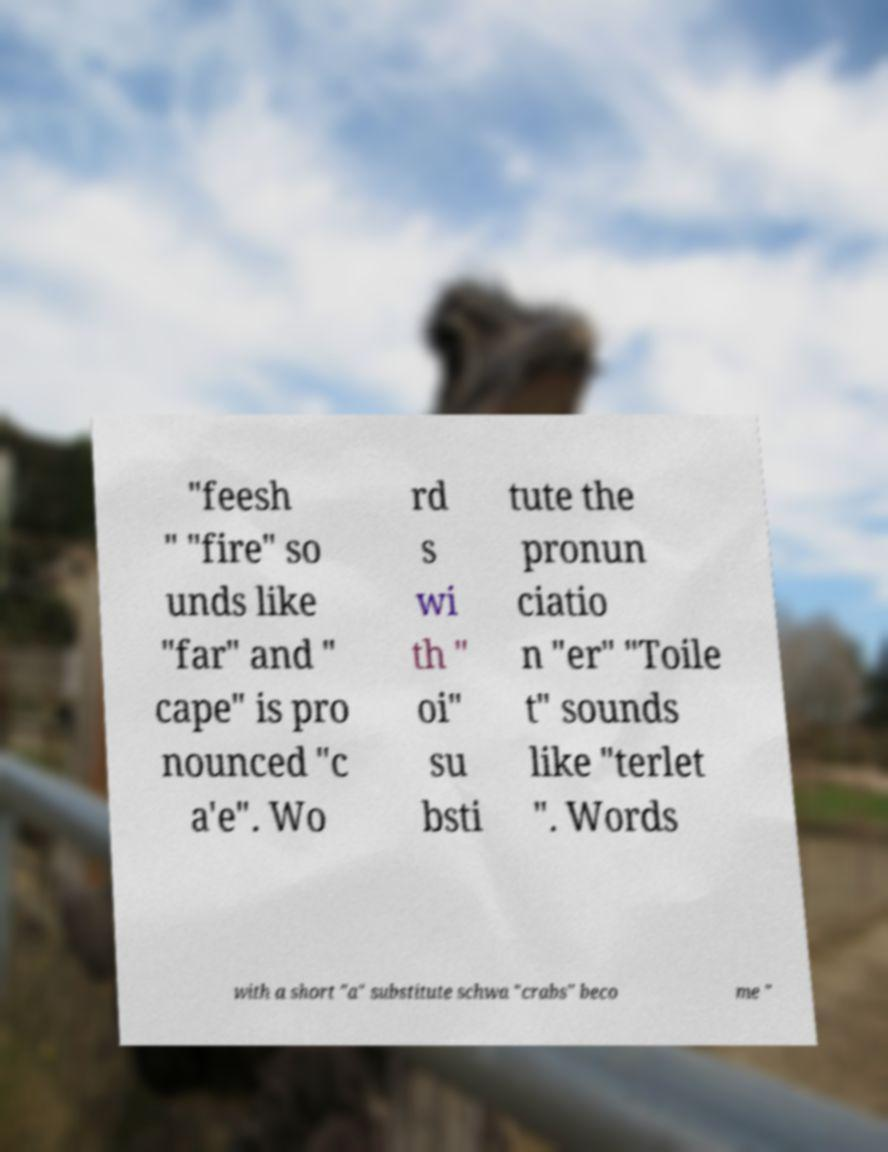I need the written content from this picture converted into text. Can you do that? "feesh " "fire" so unds like "far" and " cape" is pro nounced "c a'e". Wo rd s wi th " oi" su bsti tute the pronun ciatio n "er" "Toile t" sounds like "terlet ". Words with a short "a" substitute schwa "crabs" beco me " 